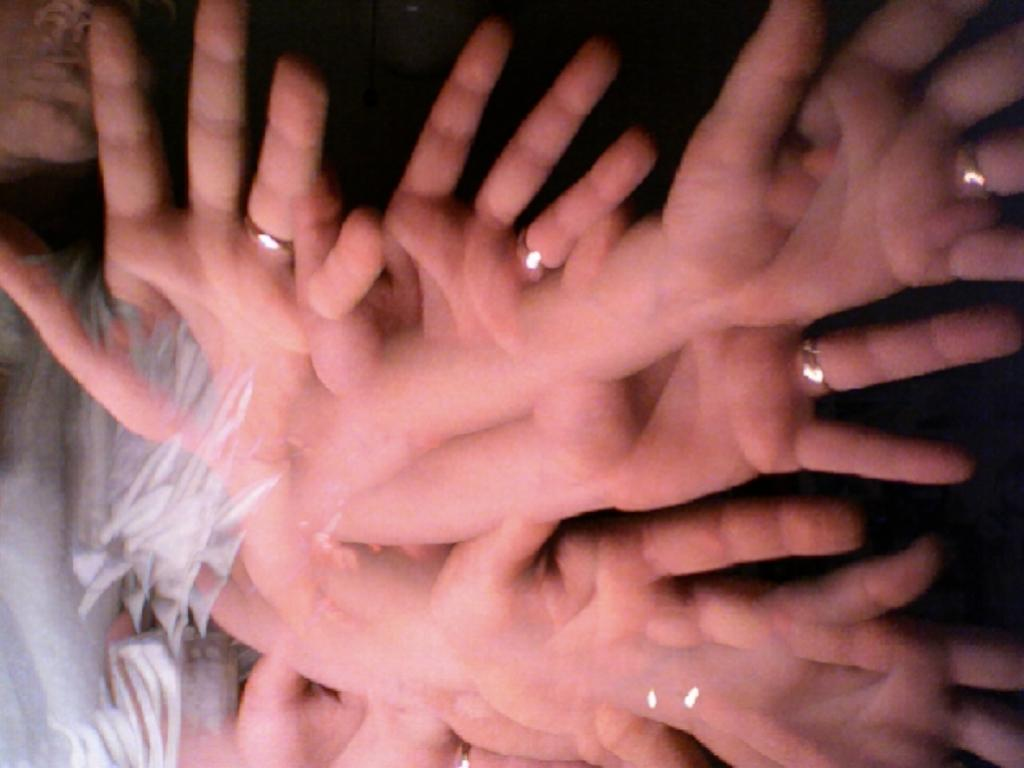What body parts are visible in the image? There are persons' hands visible in the image. What type of degree is being awarded to the person in the image? There is no person or degree present in the image; only hands are visible. 